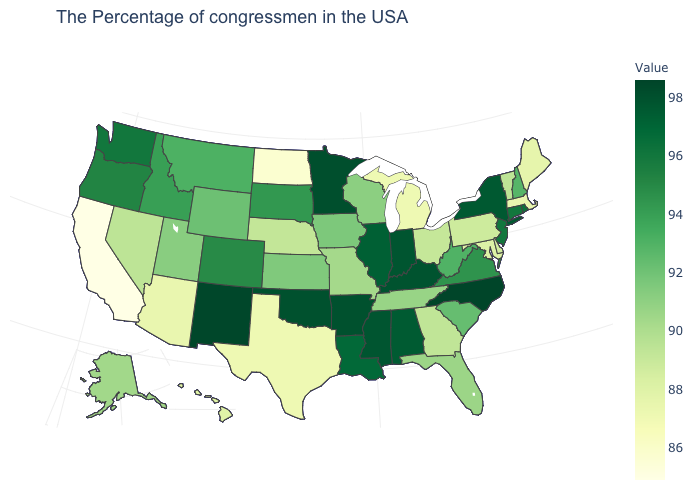Which states have the lowest value in the South?
Concise answer only. Texas. Does California have the lowest value in the USA?
Give a very brief answer. Yes. Among the states that border Wisconsin , does Minnesota have the highest value?
Be succinct. Yes. Which states have the lowest value in the USA?
Short answer required. California. Among the states that border Arkansas , does Texas have the lowest value?
Quick response, please. Yes. Does Utah have the highest value in the West?
Keep it brief. No. Which states have the lowest value in the USA?
Short answer required. California. Does California have the lowest value in the USA?
Keep it brief. Yes. 